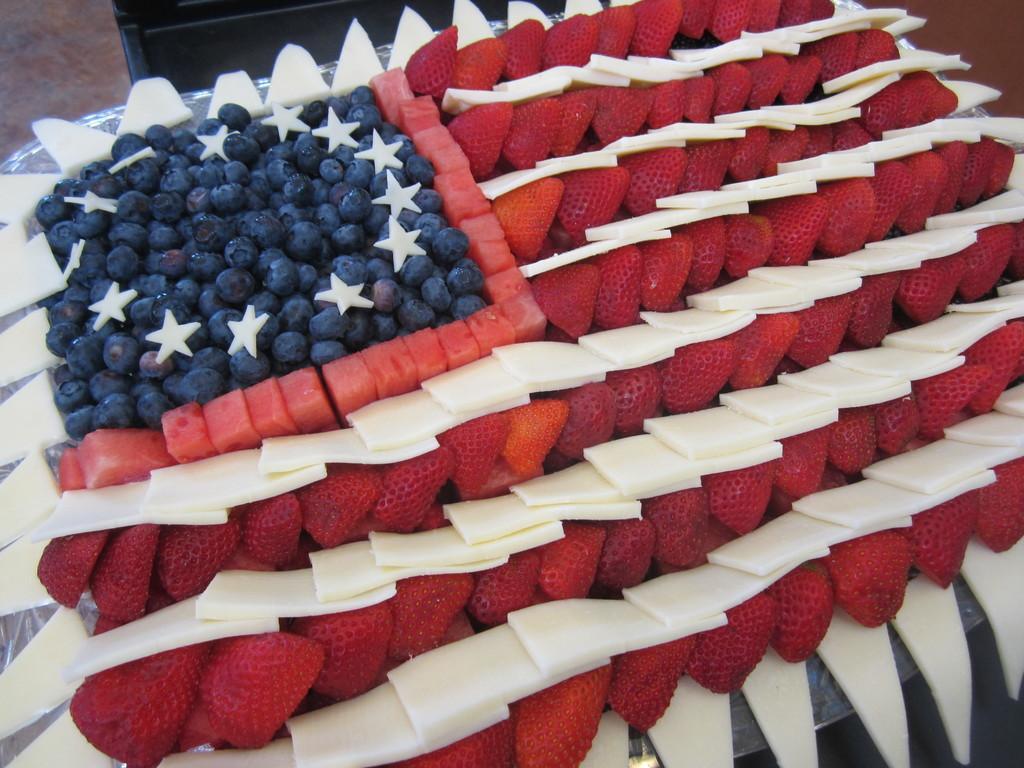Please provide a concise description of this image. In this image, we can see strawberries, grapes, watermelon slices and some other sites which are in white color. At the top, there is a silver color tray and we can see a black color object. 